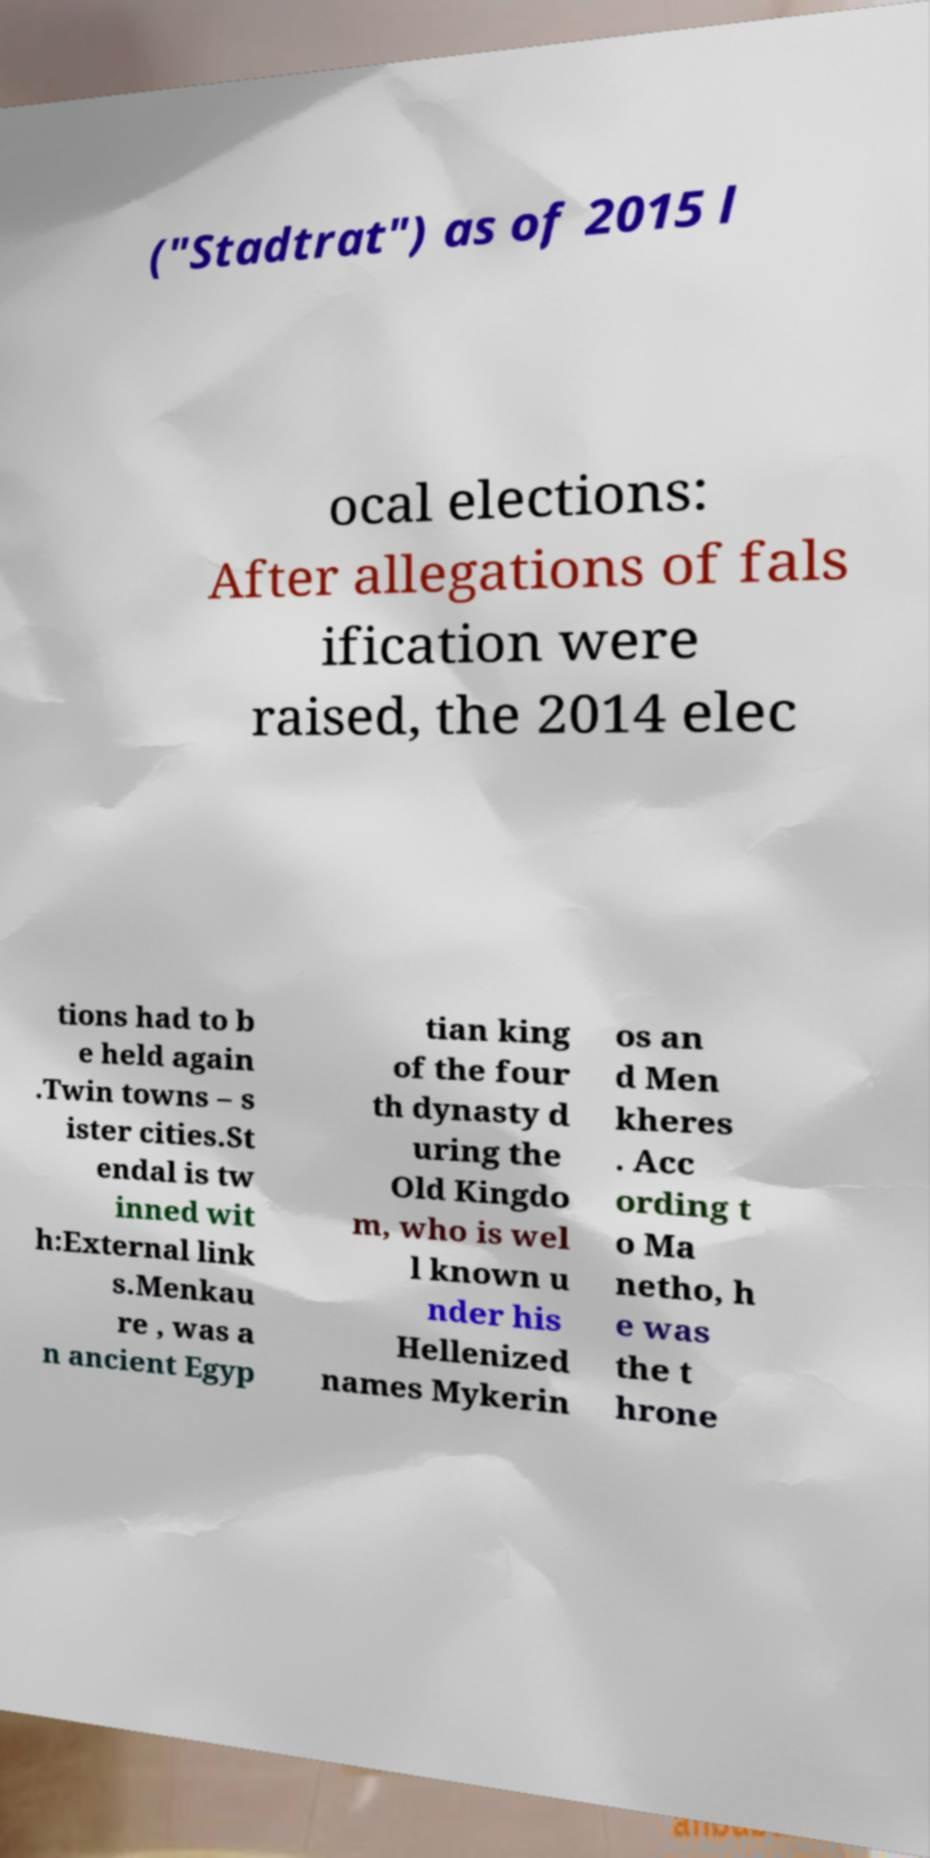What messages or text are displayed in this image? I need them in a readable, typed format. ("Stadtrat") as of 2015 l ocal elections: After allegations of fals ification were raised, the 2014 elec tions had to b e held again .Twin towns – s ister cities.St endal is tw inned wit h:External link s.Menkau re , was a n ancient Egyp tian king of the four th dynasty d uring the Old Kingdo m, who is wel l known u nder his Hellenized names Mykerin os an d Men kheres . Acc ording t o Ma netho, h e was the t hrone 